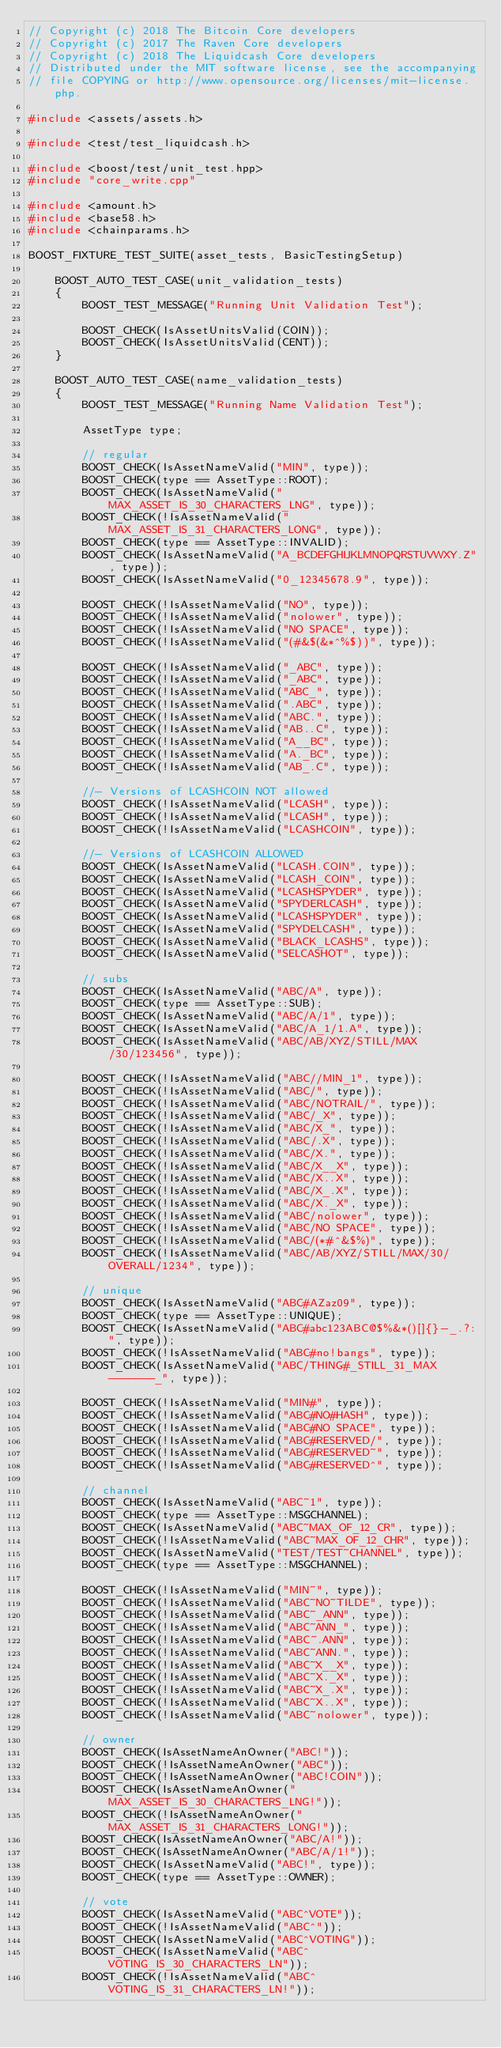Convert code to text. <code><loc_0><loc_0><loc_500><loc_500><_C++_>// Copyright (c) 2018 The Bitcoin Core developers
// Copyright (c) 2017 The Raven Core developers
// Copyright (c) 2018 The Liquidcash Core developers
// Distributed under the MIT software license, see the accompanying
// file COPYING or http://www.opensource.org/licenses/mit-license.php.

#include <assets/assets.h>

#include <test/test_liquidcash.h>

#include <boost/test/unit_test.hpp>
#include "core_write.cpp"

#include <amount.h>
#include <base58.h>
#include <chainparams.h>

BOOST_FIXTURE_TEST_SUITE(asset_tests, BasicTestingSetup)

    BOOST_AUTO_TEST_CASE(unit_validation_tests)
    {
        BOOST_TEST_MESSAGE("Running Unit Validation Test");

        BOOST_CHECK(IsAssetUnitsValid(COIN));
        BOOST_CHECK(IsAssetUnitsValid(CENT));
    }

    BOOST_AUTO_TEST_CASE(name_validation_tests)
    {
        BOOST_TEST_MESSAGE("Running Name Validation Test");

        AssetType type;

        // regular
        BOOST_CHECK(IsAssetNameValid("MIN", type));
        BOOST_CHECK(type == AssetType::ROOT);
        BOOST_CHECK(IsAssetNameValid("MAX_ASSET_IS_30_CHARACTERS_LNG", type));
        BOOST_CHECK(!IsAssetNameValid("MAX_ASSET_IS_31_CHARACTERS_LONG", type));
        BOOST_CHECK(type == AssetType::INVALID);
        BOOST_CHECK(IsAssetNameValid("A_BCDEFGHIJKLMNOPQRSTUVWXY.Z", type));
        BOOST_CHECK(IsAssetNameValid("0_12345678.9", type));

        BOOST_CHECK(!IsAssetNameValid("NO", type));
        BOOST_CHECK(!IsAssetNameValid("nolower", type));
        BOOST_CHECK(!IsAssetNameValid("NO SPACE", type));
        BOOST_CHECK(!IsAssetNameValid("(#&$(&*^%$))", type));

        BOOST_CHECK(!IsAssetNameValid("_ABC", type));
        BOOST_CHECK(!IsAssetNameValid("_ABC", type));
        BOOST_CHECK(!IsAssetNameValid("ABC_", type));
        BOOST_CHECK(!IsAssetNameValid(".ABC", type));
        BOOST_CHECK(!IsAssetNameValid("ABC.", type));
        BOOST_CHECK(!IsAssetNameValid("AB..C", type));
        BOOST_CHECK(!IsAssetNameValid("A__BC", type));
        BOOST_CHECK(!IsAssetNameValid("A._BC", type));
        BOOST_CHECK(!IsAssetNameValid("AB_.C", type));

        //- Versions of LCASHCOIN NOT allowed
        BOOST_CHECK(!IsAssetNameValid("LCASH", type));
        BOOST_CHECK(!IsAssetNameValid("LCASH", type));
        BOOST_CHECK(!IsAssetNameValid("LCASHCOIN", type));

        //- Versions of LCASHCOIN ALLOWED
        BOOST_CHECK(IsAssetNameValid("LCASH.COIN", type));
        BOOST_CHECK(IsAssetNameValid("LCASH_COIN", type));
        BOOST_CHECK(IsAssetNameValid("LCASHSPYDER", type));
        BOOST_CHECK(IsAssetNameValid("SPYDERLCASH", type));
        BOOST_CHECK(IsAssetNameValid("LCASHSPYDER", type));
        BOOST_CHECK(IsAssetNameValid("SPYDELCASH", type));
        BOOST_CHECK(IsAssetNameValid("BLACK_LCASHS", type));
        BOOST_CHECK(IsAssetNameValid("SELCASHOT", type));

        // subs
        BOOST_CHECK(IsAssetNameValid("ABC/A", type));
        BOOST_CHECK(type == AssetType::SUB);
        BOOST_CHECK(IsAssetNameValid("ABC/A/1", type));
        BOOST_CHECK(IsAssetNameValid("ABC/A_1/1.A", type));
        BOOST_CHECK(IsAssetNameValid("ABC/AB/XYZ/STILL/MAX/30/123456", type));

        BOOST_CHECK(!IsAssetNameValid("ABC//MIN_1", type));
        BOOST_CHECK(!IsAssetNameValid("ABC/", type));
        BOOST_CHECK(!IsAssetNameValid("ABC/NOTRAIL/", type));
        BOOST_CHECK(!IsAssetNameValid("ABC/_X", type));
        BOOST_CHECK(!IsAssetNameValid("ABC/X_", type));
        BOOST_CHECK(!IsAssetNameValid("ABC/.X", type));
        BOOST_CHECK(!IsAssetNameValid("ABC/X.", type));
        BOOST_CHECK(!IsAssetNameValid("ABC/X__X", type));
        BOOST_CHECK(!IsAssetNameValid("ABC/X..X", type));
        BOOST_CHECK(!IsAssetNameValid("ABC/X_.X", type));
        BOOST_CHECK(!IsAssetNameValid("ABC/X._X", type));
        BOOST_CHECK(!IsAssetNameValid("ABC/nolower", type));
        BOOST_CHECK(!IsAssetNameValid("ABC/NO SPACE", type));
        BOOST_CHECK(!IsAssetNameValid("ABC/(*#^&$%)", type));
        BOOST_CHECK(!IsAssetNameValid("ABC/AB/XYZ/STILL/MAX/30/OVERALL/1234", type));

        // unique
        BOOST_CHECK(IsAssetNameValid("ABC#AZaz09", type));
        BOOST_CHECK(type == AssetType::UNIQUE);
        BOOST_CHECK(IsAssetNameValid("ABC#abc123ABC@$%&*()[]{}-_.?:", type));
        BOOST_CHECK(!IsAssetNameValid("ABC#no!bangs", type));
        BOOST_CHECK(IsAssetNameValid("ABC/THING#_STILL_31_MAX-------_", type));

        BOOST_CHECK(!IsAssetNameValid("MIN#", type));
        BOOST_CHECK(!IsAssetNameValid("ABC#NO#HASH", type));
        BOOST_CHECK(!IsAssetNameValid("ABC#NO SPACE", type));
        BOOST_CHECK(!IsAssetNameValid("ABC#RESERVED/", type));
        BOOST_CHECK(!IsAssetNameValid("ABC#RESERVED~", type));
        BOOST_CHECK(!IsAssetNameValid("ABC#RESERVED^", type));

        // channel
        BOOST_CHECK(IsAssetNameValid("ABC~1", type));
        BOOST_CHECK(type == AssetType::MSGCHANNEL);
        BOOST_CHECK(IsAssetNameValid("ABC~MAX_OF_12_CR", type));
        BOOST_CHECK(!IsAssetNameValid("ABC~MAX_OF_12_CHR", type));
        BOOST_CHECK(IsAssetNameValid("TEST/TEST~CHANNEL", type));
        BOOST_CHECK(type == AssetType::MSGCHANNEL);

        BOOST_CHECK(!IsAssetNameValid("MIN~", type));
        BOOST_CHECK(!IsAssetNameValid("ABC~NO~TILDE", type));
        BOOST_CHECK(!IsAssetNameValid("ABC~_ANN", type));
        BOOST_CHECK(!IsAssetNameValid("ABC~ANN_", type));
        BOOST_CHECK(!IsAssetNameValid("ABC~.ANN", type));
        BOOST_CHECK(!IsAssetNameValid("ABC~ANN.", type));
        BOOST_CHECK(!IsAssetNameValid("ABC~X__X", type));
        BOOST_CHECK(!IsAssetNameValid("ABC~X._X", type));
        BOOST_CHECK(!IsAssetNameValid("ABC~X_.X", type));
        BOOST_CHECK(!IsAssetNameValid("ABC~X..X", type));
        BOOST_CHECK(!IsAssetNameValid("ABC~nolower", type));

        // owner
        BOOST_CHECK(IsAssetNameAnOwner("ABC!"));
        BOOST_CHECK(!IsAssetNameAnOwner("ABC"));
        BOOST_CHECK(!IsAssetNameAnOwner("ABC!COIN"));
        BOOST_CHECK(IsAssetNameAnOwner("MAX_ASSET_IS_30_CHARACTERS_LNG!"));
        BOOST_CHECK(!IsAssetNameAnOwner("MAX_ASSET_IS_31_CHARACTERS_LONG!"));
        BOOST_CHECK(IsAssetNameAnOwner("ABC/A!"));
        BOOST_CHECK(IsAssetNameAnOwner("ABC/A/1!"));
        BOOST_CHECK(IsAssetNameValid("ABC!", type));
        BOOST_CHECK(type == AssetType::OWNER);

        // vote
        BOOST_CHECK(IsAssetNameValid("ABC^VOTE"));
        BOOST_CHECK(!IsAssetNameValid("ABC^"));
        BOOST_CHECK(IsAssetNameValid("ABC^VOTING"));
        BOOST_CHECK(IsAssetNameValid("ABC^VOTING_IS_30_CHARACTERS_LN"));
        BOOST_CHECK(!IsAssetNameValid("ABC^VOTING_IS_31_CHARACTERS_LN!"));</code> 